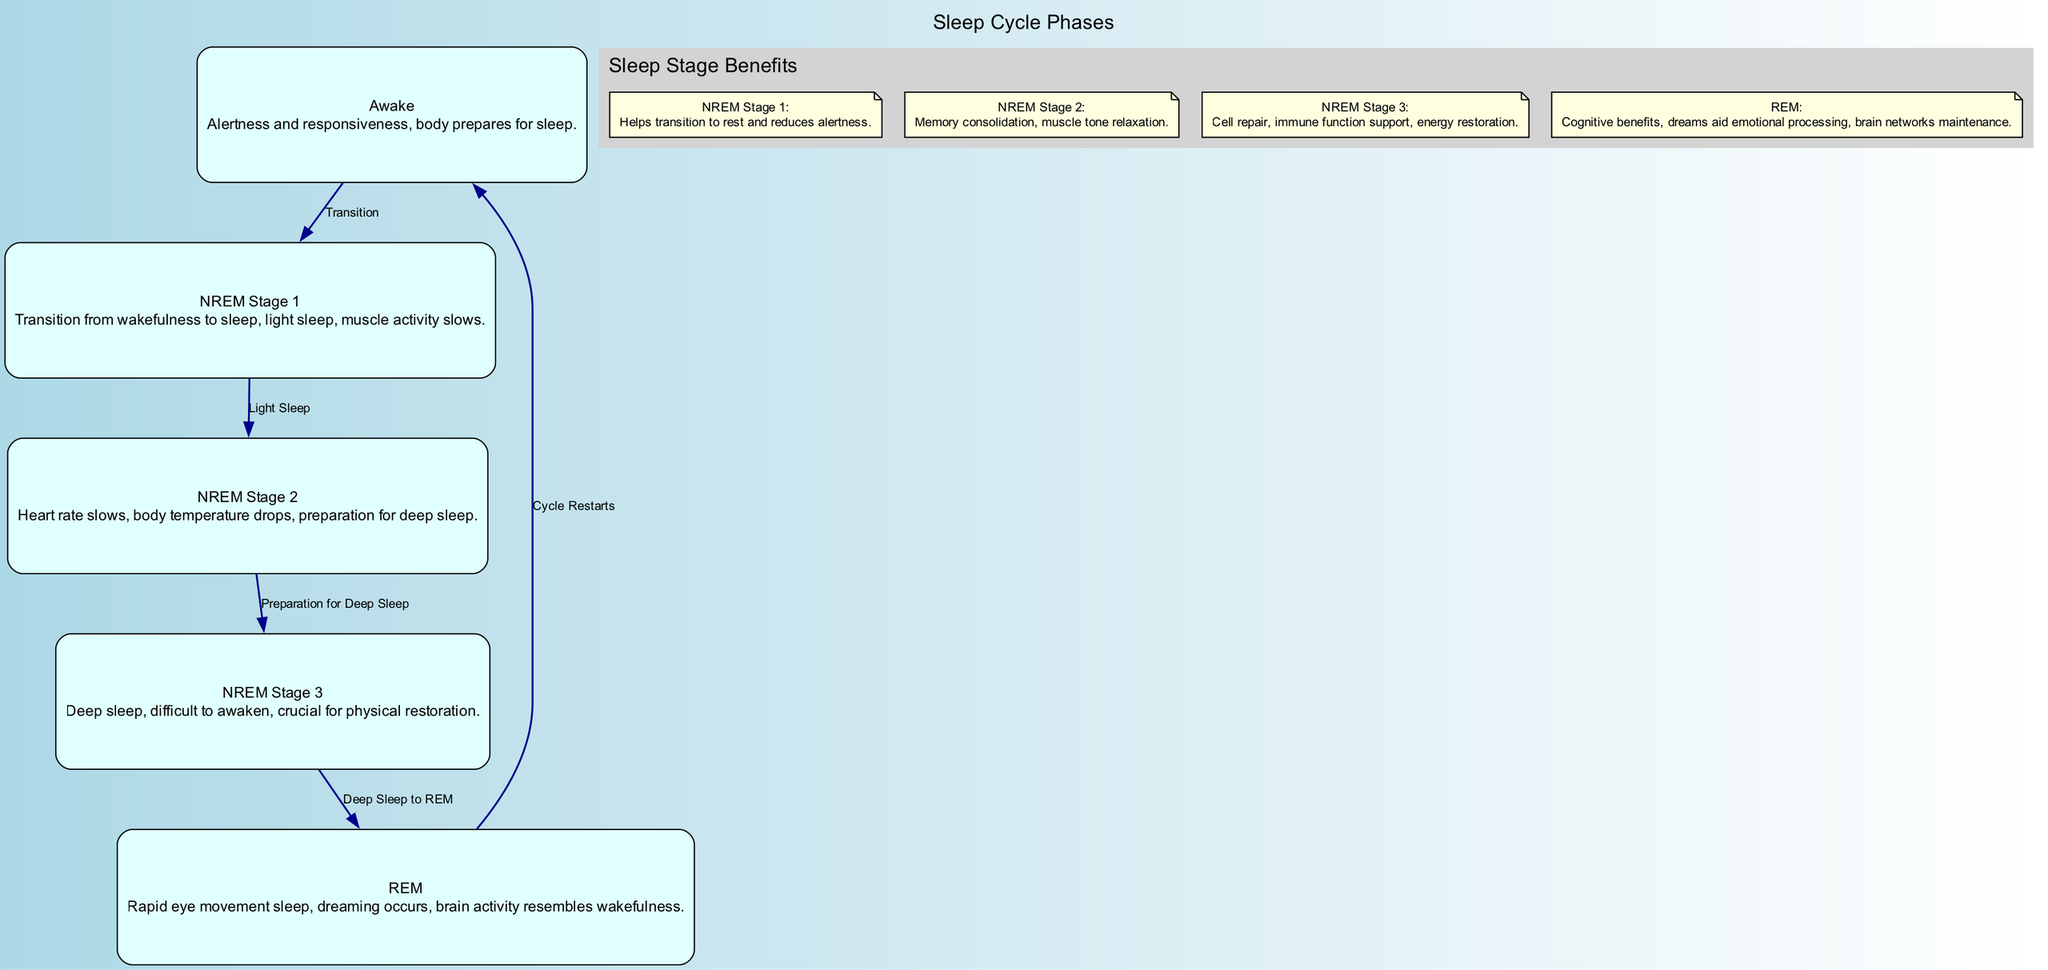What are the stages of sleep depicted in the diagram? The diagram outlines five stages of sleep, which are: Awake, NREM Stage 1, NREM Stage 2, NREM Stage 3, and REM. These nodes represent the different phases of sleep experienced during a cycle.
Answer: Awake, NREM Stage 1, NREM Stage 2, NREM Stage 3, REM How many edges are in the sleep cycle diagram? The diagram includes five edges that show the transitions between the different stages of sleep. Each edge represents a specific relationship or transition from one sleep stage to another.
Answer: 5 What benefit is associated with NREM Stage 3? According to the benefits listed in the diagram, NREM Stage 3 provides benefits such as cell repair, immune function support, and energy restoration. It highlights the importance of this deep sleep stage for bodily recovery.
Answer: Cell repair, immune function support, energy restoration What stage follows NREM Stage 2? The diagram indicates that NREM Stage 3 follows NREM Stage 2. This transition is labeled as "Light Sleep" in the edge that connects these two nodes, emphasizing the progression towards deeper sleep.
Answer: NREM Stage 3 Which stage is characterized by dreaming? The diagram illustrates that the REM stage is characterized by rapid eye movement and dreaming. It highlights how this stage is crucial for cognitive processes and emotional processing, which is typical during dreams.
Answer: REM 